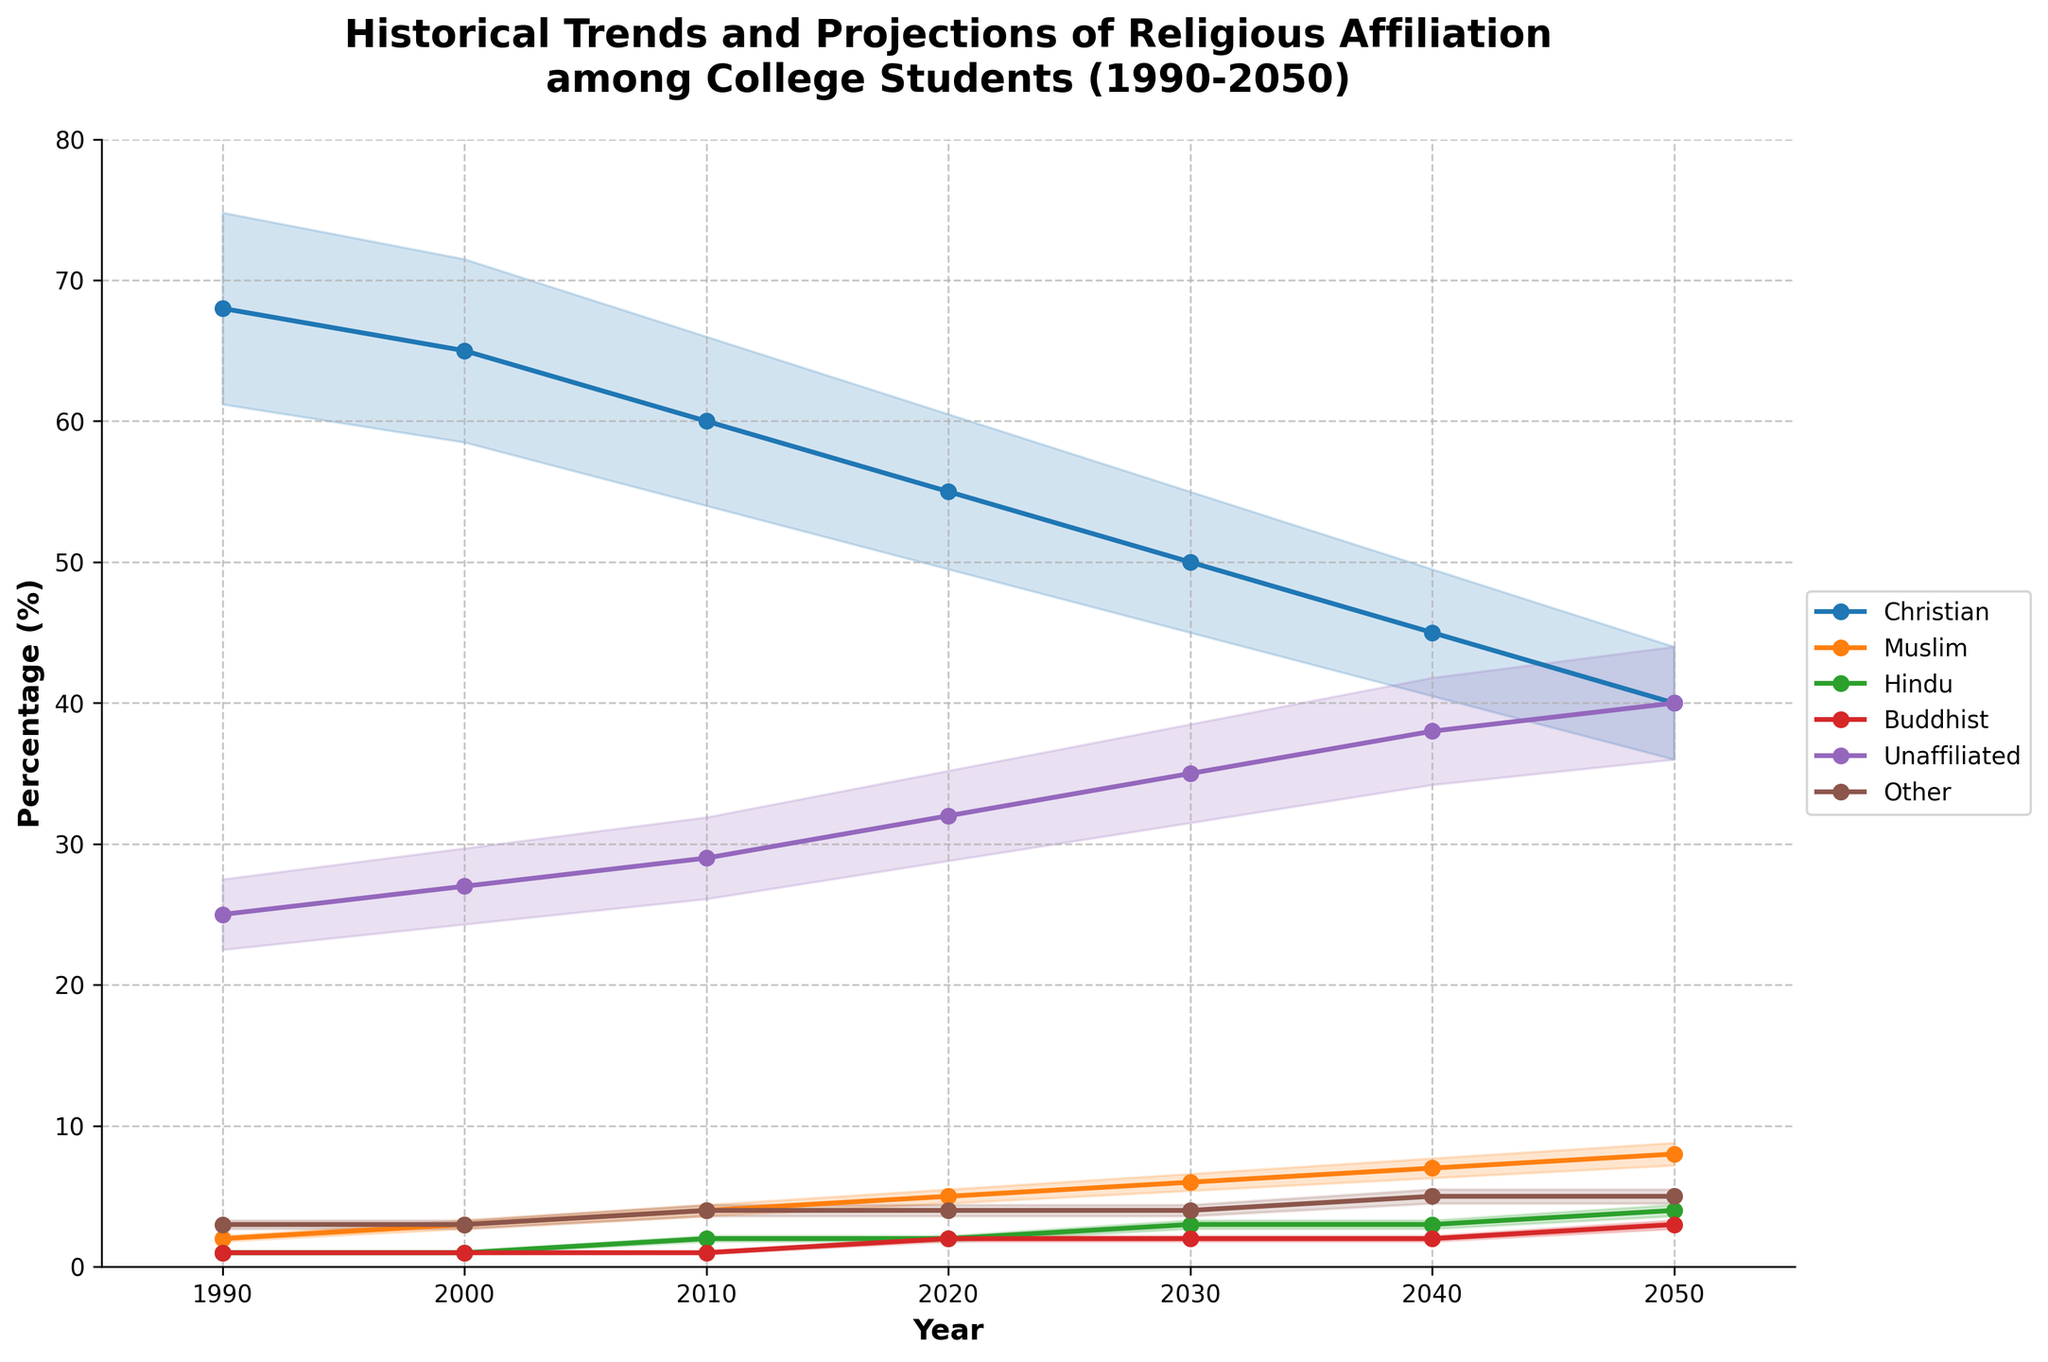What is the title of the chart? The title of the chart is displayed at the top and provides an overview of the content. It reads 'Historical Trends and Projections of Religious Affiliation among College Students (1990-2050)'.
Answer: Historical Trends and Projections of Religious Affiliation among College Students (1990-2050) Which religious group had the highest percentage in 1990? By looking at the left end of the plot at the year 1990, we can see that Christians had the highest percentage of 68%.
Answer: Christians How much does the percentage of unaffiliated students increase from 1990 to 2050? By comparing the unaffiliated percentage in 1990 (25%) to the projected percentage in 2050 (40%), the increase can be calculated as 40% - 25% = 15%.
Answer: 15% Which religious group has a projected increase in percentage from 2020 to 2050? Reviewing the projections from 2020 to 2050, Muslims and Hindus show an increase in their percentages over these years. Muslims increase from 5% to 8% and Hindus from 2% to 4%.
Answer: Muslims and Hindus What is the percentage of Buddhists in 2030? Locate the year 2030 on the x-axis and find the corresponding value for Buddhists, which is projected to be 2%.
Answer: 2% Between which two years did Christians see the largest decline in percentage? By examining the plot, the largest drop appears between 2020 and 2030, where the percentage decreases from 55% to 50% for Christians.
Answer: 2020 and 2030 How does the percentage of the 'Other' category change over the time period? The percentage for the 'Other' category starts at 3% in 1990 and increases to 5% by 2050, as shown by the plot.
Answer: Increases from 3% to 5% Which group shows the least amount of change from 1990 to 2050? By observing the bands, Buddhists exhibit minimal change with a slight increase from 1% to 3%, and this is relatively small compared to other groups.
Answer: Buddhists What percentage of Muslims is projected in 2040? At the year 2040 on the x-axis, the percentage for Muslims can be identified as 7%.
Answer: 7% Which group is projected to have the highest percentage in 2050? The plot shows that by 2050, the unaffiliated group is projected to have the highest percentage at 40%, surpassing Christians.
Answer: Unaffiliated 